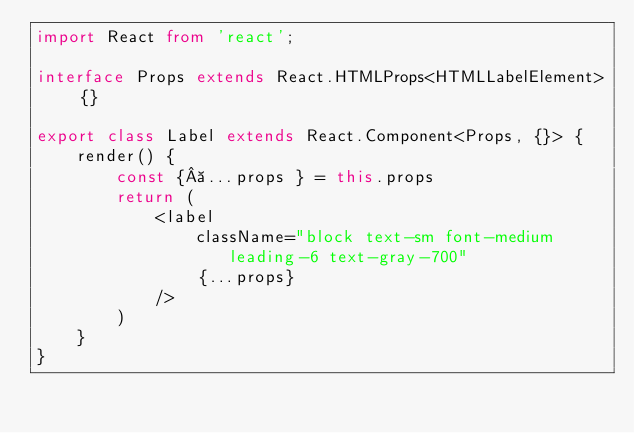Convert code to text. <code><loc_0><loc_0><loc_500><loc_500><_TypeScript_>import React from 'react';

interface Props extends React.HTMLProps<HTMLLabelElement> {}

export class Label extends React.Component<Props, {}> {
    render() {
        const { ...props } = this.props
        return (
            <label
                className="block text-sm font-medium leading-6 text-gray-700"
                {...props}
            />
        )
    }
}</code> 